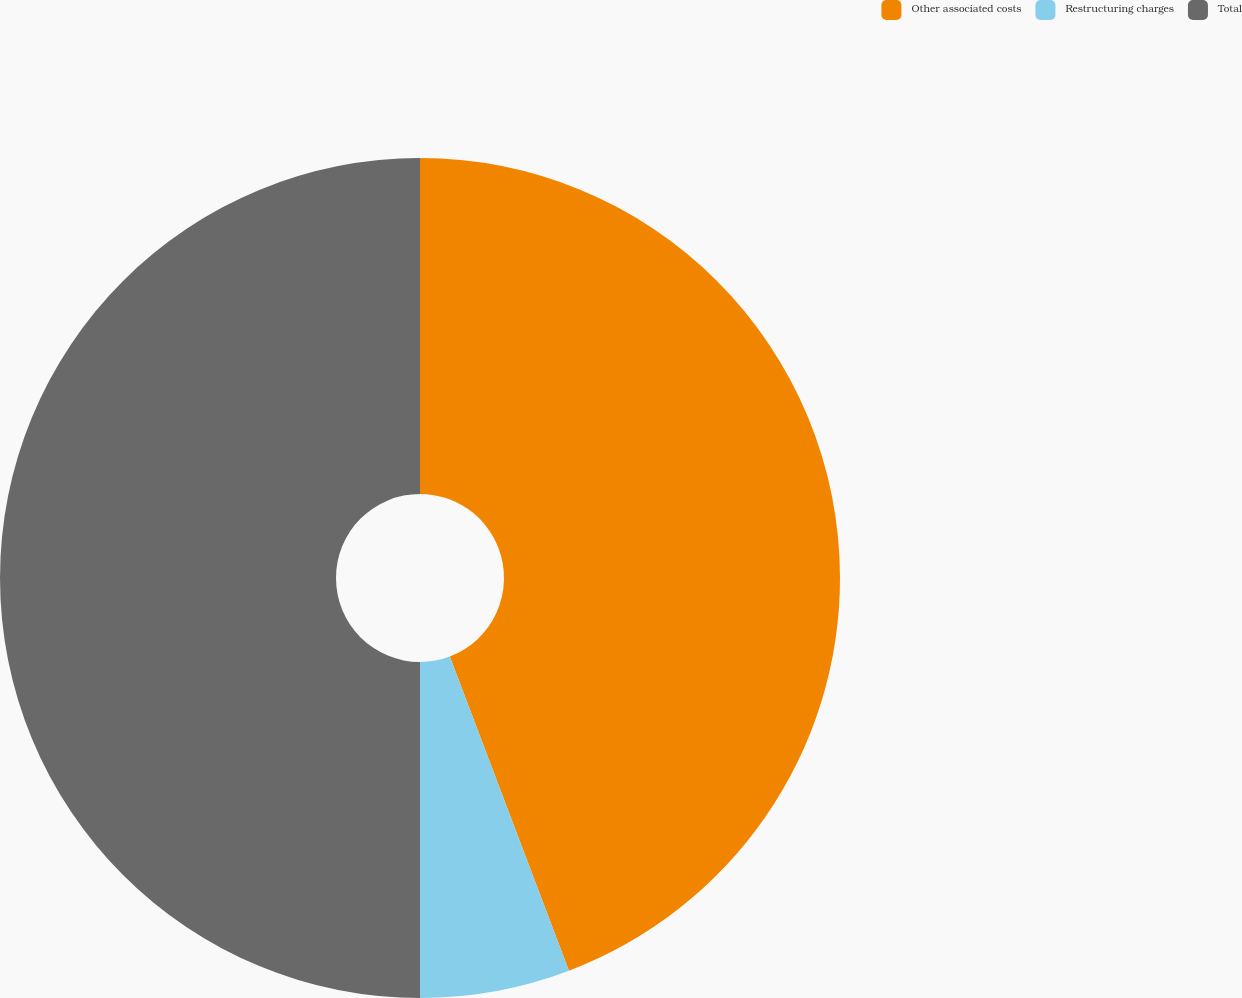<chart> <loc_0><loc_0><loc_500><loc_500><pie_chart><fcel>Other associated costs<fcel>Restructuring charges<fcel>Total<nl><fcel>44.23%<fcel>5.77%<fcel>50.0%<nl></chart> 